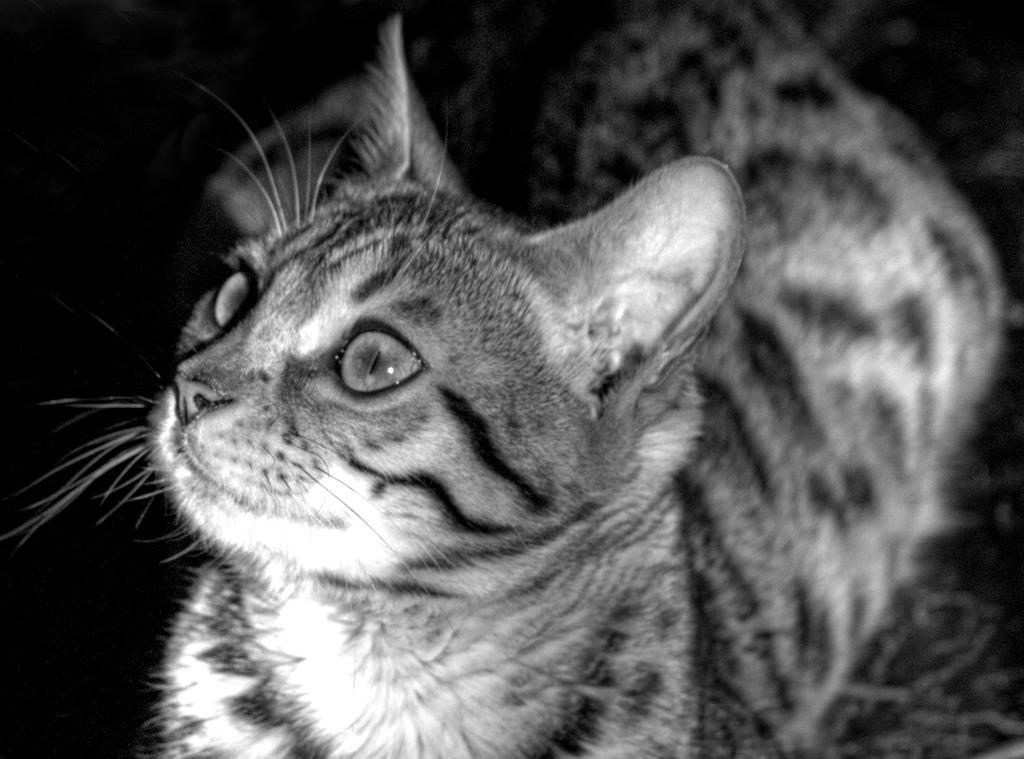What type of animal is present in the image? There is a cat in the image. What type of beggar is present in the image? There is no beggar present in the image; it only features a cat. What type of ground can be seen beneath the cat in the image? The fact provided does not mention any ground or surface beneath the cat, so it cannot be determined from the image. 